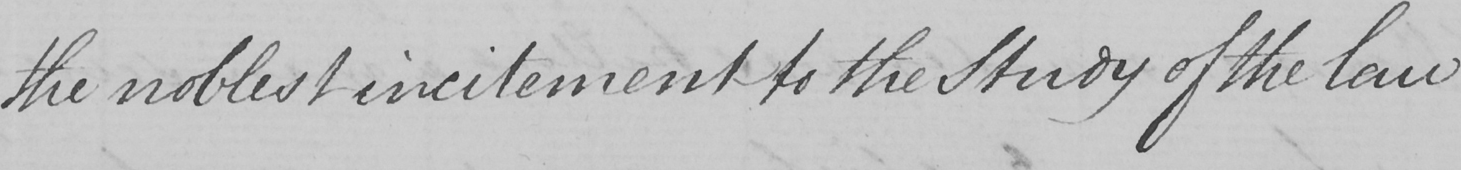Can you read and transcribe this handwriting? the noblest incitement to the Study of the law 